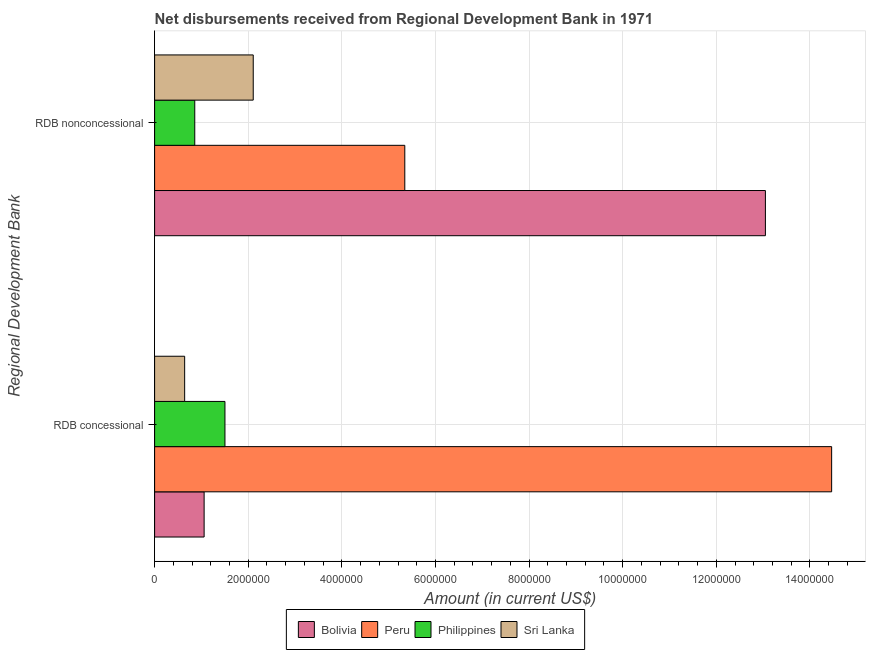How many different coloured bars are there?
Provide a succinct answer. 4. How many groups of bars are there?
Your answer should be very brief. 2. Are the number of bars on each tick of the Y-axis equal?
Make the answer very short. Yes. How many bars are there on the 2nd tick from the top?
Your response must be concise. 4. What is the label of the 2nd group of bars from the top?
Ensure brevity in your answer.  RDB concessional. What is the net concessional disbursements from rdb in Philippines?
Keep it short and to the point. 1.50e+06. Across all countries, what is the maximum net non concessional disbursements from rdb?
Your response must be concise. 1.30e+07. Across all countries, what is the minimum net concessional disbursements from rdb?
Provide a short and direct response. 6.42e+05. What is the total net concessional disbursements from rdb in the graph?
Provide a succinct answer. 1.77e+07. What is the difference between the net non concessional disbursements from rdb in Peru and that in Sri Lanka?
Make the answer very short. 3.24e+06. What is the difference between the net non concessional disbursements from rdb in Sri Lanka and the net concessional disbursements from rdb in Bolivia?
Provide a short and direct response. 1.05e+06. What is the average net concessional disbursements from rdb per country?
Provide a short and direct response. 4.42e+06. What is the difference between the net concessional disbursements from rdb and net non concessional disbursements from rdb in Peru?
Provide a succinct answer. 9.12e+06. In how many countries, is the net non concessional disbursements from rdb greater than 3200000 US$?
Offer a very short reply. 2. What is the ratio of the net non concessional disbursements from rdb in Peru to that in Sri Lanka?
Provide a succinct answer. 2.54. What does the 2nd bar from the top in RDB concessional represents?
Provide a succinct answer. Philippines. What does the 4th bar from the bottom in RDB concessional represents?
Make the answer very short. Sri Lanka. How many bars are there?
Your response must be concise. 8. Are all the bars in the graph horizontal?
Provide a succinct answer. Yes. Does the graph contain any zero values?
Keep it short and to the point. No. Does the graph contain grids?
Keep it short and to the point. Yes. Where does the legend appear in the graph?
Keep it short and to the point. Bottom center. How are the legend labels stacked?
Your response must be concise. Horizontal. What is the title of the graph?
Make the answer very short. Net disbursements received from Regional Development Bank in 1971. What is the label or title of the Y-axis?
Keep it short and to the point. Regional Development Bank. What is the Amount (in current US$) in Bolivia in RDB concessional?
Provide a succinct answer. 1.06e+06. What is the Amount (in current US$) of Peru in RDB concessional?
Your answer should be compact. 1.45e+07. What is the Amount (in current US$) of Philippines in RDB concessional?
Your answer should be very brief. 1.50e+06. What is the Amount (in current US$) of Sri Lanka in RDB concessional?
Offer a terse response. 6.42e+05. What is the Amount (in current US$) of Bolivia in RDB nonconcessional?
Keep it short and to the point. 1.30e+07. What is the Amount (in current US$) of Peru in RDB nonconcessional?
Give a very brief answer. 5.34e+06. What is the Amount (in current US$) in Philippines in RDB nonconcessional?
Make the answer very short. 8.58e+05. What is the Amount (in current US$) in Sri Lanka in RDB nonconcessional?
Offer a very short reply. 2.11e+06. Across all Regional Development Bank, what is the maximum Amount (in current US$) of Bolivia?
Ensure brevity in your answer.  1.30e+07. Across all Regional Development Bank, what is the maximum Amount (in current US$) in Peru?
Keep it short and to the point. 1.45e+07. Across all Regional Development Bank, what is the maximum Amount (in current US$) in Philippines?
Make the answer very short. 1.50e+06. Across all Regional Development Bank, what is the maximum Amount (in current US$) of Sri Lanka?
Your answer should be very brief. 2.11e+06. Across all Regional Development Bank, what is the minimum Amount (in current US$) of Bolivia?
Provide a succinct answer. 1.06e+06. Across all Regional Development Bank, what is the minimum Amount (in current US$) of Peru?
Your response must be concise. 5.34e+06. Across all Regional Development Bank, what is the minimum Amount (in current US$) of Philippines?
Your answer should be very brief. 8.58e+05. Across all Regional Development Bank, what is the minimum Amount (in current US$) in Sri Lanka?
Your answer should be very brief. 6.42e+05. What is the total Amount (in current US$) in Bolivia in the graph?
Make the answer very short. 1.41e+07. What is the total Amount (in current US$) in Peru in the graph?
Give a very brief answer. 1.98e+07. What is the total Amount (in current US$) of Philippines in the graph?
Give a very brief answer. 2.36e+06. What is the total Amount (in current US$) in Sri Lanka in the graph?
Make the answer very short. 2.75e+06. What is the difference between the Amount (in current US$) of Bolivia in RDB concessional and that in RDB nonconcessional?
Your answer should be very brief. -1.20e+07. What is the difference between the Amount (in current US$) in Peru in RDB concessional and that in RDB nonconcessional?
Your response must be concise. 9.12e+06. What is the difference between the Amount (in current US$) of Philippines in RDB concessional and that in RDB nonconcessional?
Offer a terse response. 6.45e+05. What is the difference between the Amount (in current US$) of Sri Lanka in RDB concessional and that in RDB nonconcessional?
Your response must be concise. -1.46e+06. What is the difference between the Amount (in current US$) of Bolivia in RDB concessional and the Amount (in current US$) of Peru in RDB nonconcessional?
Make the answer very short. -4.29e+06. What is the difference between the Amount (in current US$) of Bolivia in RDB concessional and the Amount (in current US$) of Sri Lanka in RDB nonconcessional?
Keep it short and to the point. -1.05e+06. What is the difference between the Amount (in current US$) of Peru in RDB concessional and the Amount (in current US$) of Philippines in RDB nonconcessional?
Make the answer very short. 1.36e+07. What is the difference between the Amount (in current US$) in Peru in RDB concessional and the Amount (in current US$) in Sri Lanka in RDB nonconcessional?
Give a very brief answer. 1.24e+07. What is the difference between the Amount (in current US$) in Philippines in RDB concessional and the Amount (in current US$) in Sri Lanka in RDB nonconcessional?
Provide a short and direct response. -6.04e+05. What is the average Amount (in current US$) in Bolivia per Regional Development Bank?
Your answer should be very brief. 7.05e+06. What is the average Amount (in current US$) in Peru per Regional Development Bank?
Your response must be concise. 9.90e+06. What is the average Amount (in current US$) of Philippines per Regional Development Bank?
Your answer should be very brief. 1.18e+06. What is the average Amount (in current US$) of Sri Lanka per Regional Development Bank?
Provide a short and direct response. 1.37e+06. What is the difference between the Amount (in current US$) in Bolivia and Amount (in current US$) in Peru in RDB concessional?
Keep it short and to the point. -1.34e+07. What is the difference between the Amount (in current US$) of Bolivia and Amount (in current US$) of Philippines in RDB concessional?
Your answer should be compact. -4.45e+05. What is the difference between the Amount (in current US$) of Bolivia and Amount (in current US$) of Sri Lanka in RDB concessional?
Ensure brevity in your answer.  4.16e+05. What is the difference between the Amount (in current US$) of Peru and Amount (in current US$) of Philippines in RDB concessional?
Provide a succinct answer. 1.30e+07. What is the difference between the Amount (in current US$) of Peru and Amount (in current US$) of Sri Lanka in RDB concessional?
Your response must be concise. 1.38e+07. What is the difference between the Amount (in current US$) of Philippines and Amount (in current US$) of Sri Lanka in RDB concessional?
Offer a very short reply. 8.61e+05. What is the difference between the Amount (in current US$) in Bolivia and Amount (in current US$) in Peru in RDB nonconcessional?
Give a very brief answer. 7.70e+06. What is the difference between the Amount (in current US$) of Bolivia and Amount (in current US$) of Philippines in RDB nonconcessional?
Keep it short and to the point. 1.22e+07. What is the difference between the Amount (in current US$) in Bolivia and Amount (in current US$) in Sri Lanka in RDB nonconcessional?
Keep it short and to the point. 1.09e+07. What is the difference between the Amount (in current US$) in Peru and Amount (in current US$) in Philippines in RDB nonconcessional?
Your answer should be compact. 4.49e+06. What is the difference between the Amount (in current US$) of Peru and Amount (in current US$) of Sri Lanka in RDB nonconcessional?
Your answer should be very brief. 3.24e+06. What is the difference between the Amount (in current US$) in Philippines and Amount (in current US$) in Sri Lanka in RDB nonconcessional?
Your answer should be compact. -1.25e+06. What is the ratio of the Amount (in current US$) of Bolivia in RDB concessional to that in RDB nonconcessional?
Your response must be concise. 0.08. What is the ratio of the Amount (in current US$) in Peru in RDB concessional to that in RDB nonconcessional?
Your answer should be compact. 2.71. What is the ratio of the Amount (in current US$) of Philippines in RDB concessional to that in RDB nonconcessional?
Make the answer very short. 1.75. What is the ratio of the Amount (in current US$) in Sri Lanka in RDB concessional to that in RDB nonconcessional?
Offer a very short reply. 0.3. What is the difference between the highest and the second highest Amount (in current US$) in Bolivia?
Keep it short and to the point. 1.20e+07. What is the difference between the highest and the second highest Amount (in current US$) in Peru?
Your answer should be compact. 9.12e+06. What is the difference between the highest and the second highest Amount (in current US$) in Philippines?
Provide a succinct answer. 6.45e+05. What is the difference between the highest and the second highest Amount (in current US$) in Sri Lanka?
Make the answer very short. 1.46e+06. What is the difference between the highest and the lowest Amount (in current US$) of Bolivia?
Provide a succinct answer. 1.20e+07. What is the difference between the highest and the lowest Amount (in current US$) of Peru?
Keep it short and to the point. 9.12e+06. What is the difference between the highest and the lowest Amount (in current US$) of Philippines?
Offer a terse response. 6.45e+05. What is the difference between the highest and the lowest Amount (in current US$) of Sri Lanka?
Offer a terse response. 1.46e+06. 